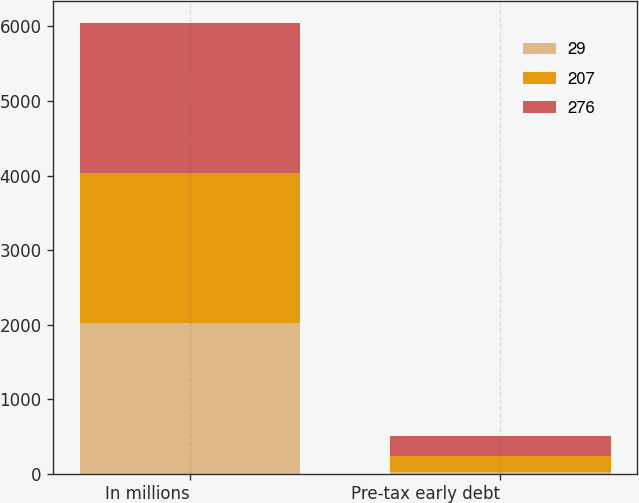<chart> <loc_0><loc_0><loc_500><loc_500><stacked_bar_chart><ecel><fcel>In millions<fcel>Pre-tax early debt<nl><fcel>29<fcel>2016<fcel>29<nl><fcel>207<fcel>2015<fcel>207<nl><fcel>276<fcel>2014<fcel>276<nl></chart> 